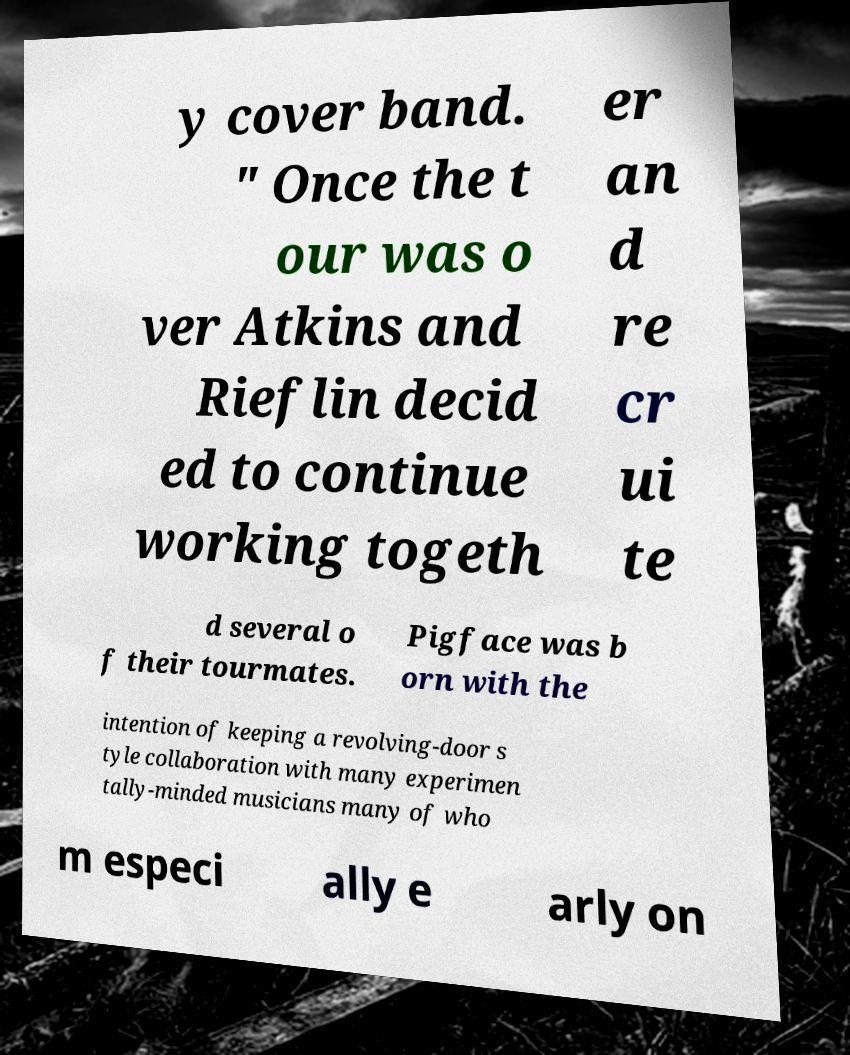Please read and relay the text visible in this image. What does it say? y cover band. " Once the t our was o ver Atkins and Rieflin decid ed to continue working togeth er an d re cr ui te d several o f their tourmates. Pigface was b orn with the intention of keeping a revolving-door s tyle collaboration with many experimen tally-minded musicians many of who m especi ally e arly on 